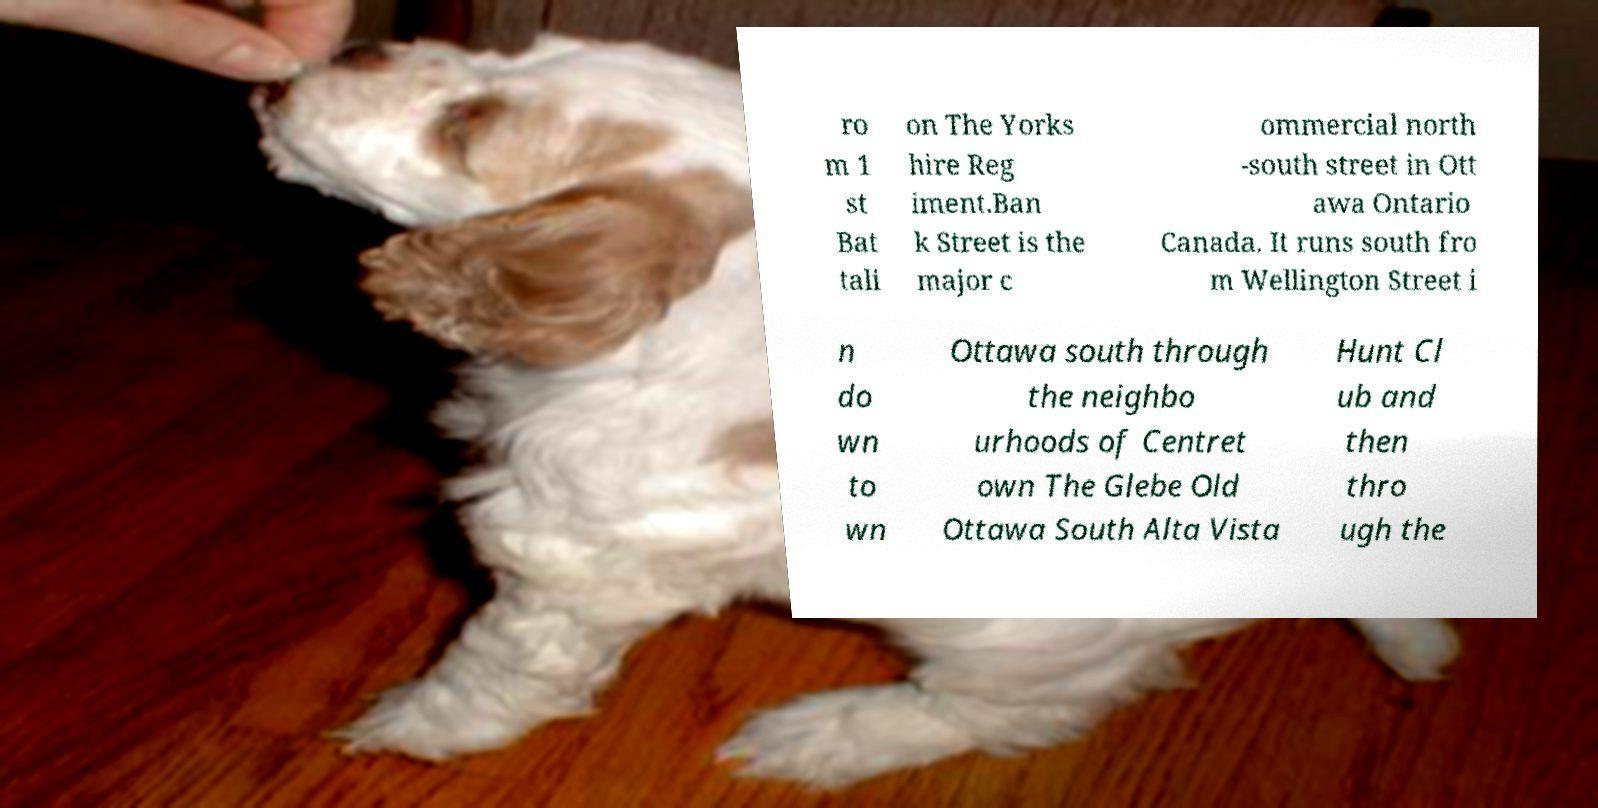Can you accurately transcribe the text from the provided image for me? ro m 1 st Bat tali on The Yorks hire Reg iment.Ban k Street is the major c ommercial north -south street in Ott awa Ontario Canada. It runs south fro m Wellington Street i n do wn to wn Ottawa south through the neighbo urhoods of Centret own The Glebe Old Ottawa South Alta Vista Hunt Cl ub and then thro ugh the 